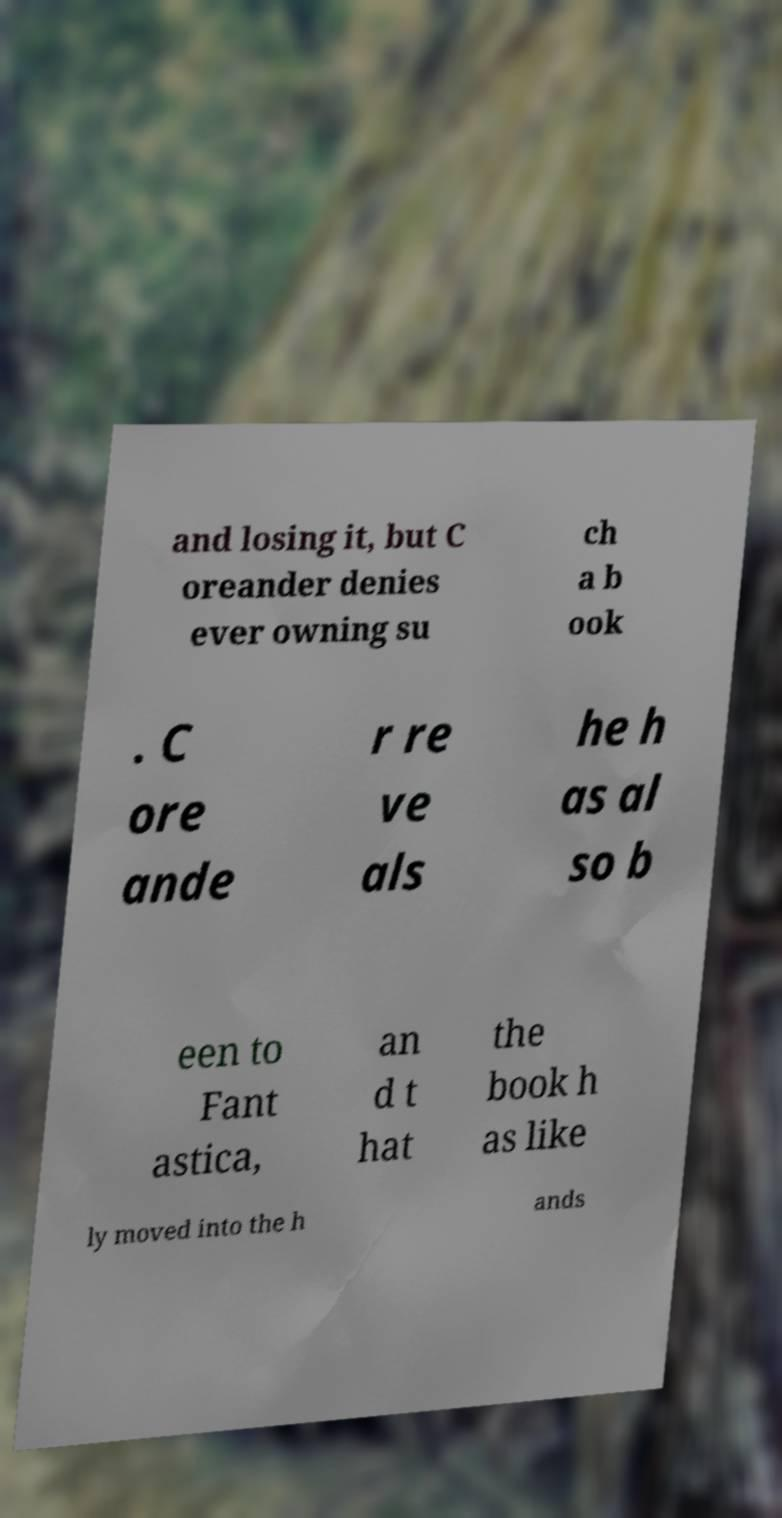What messages or text are displayed in this image? I need them in a readable, typed format. and losing it, but C oreander denies ever owning su ch a b ook . C ore ande r re ve als he h as al so b een to Fant astica, an d t hat the book h as like ly moved into the h ands 